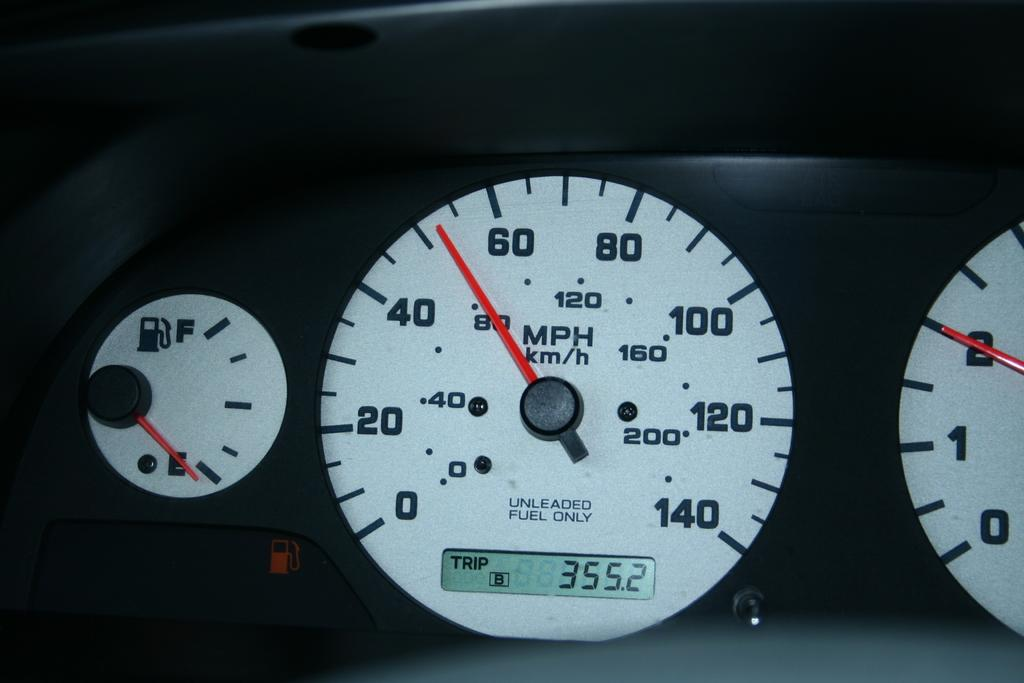What type of instrument is featured in the image? The image contains a speedometer for cars. What type of beans does the farmer grow in the image? There is no farmer or beans present in the image; it features a speedometer for cars. 